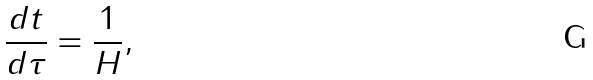Convert formula to latex. <formula><loc_0><loc_0><loc_500><loc_500>\frac { d t } { d \tau } = \frac { 1 } { H } ,</formula> 